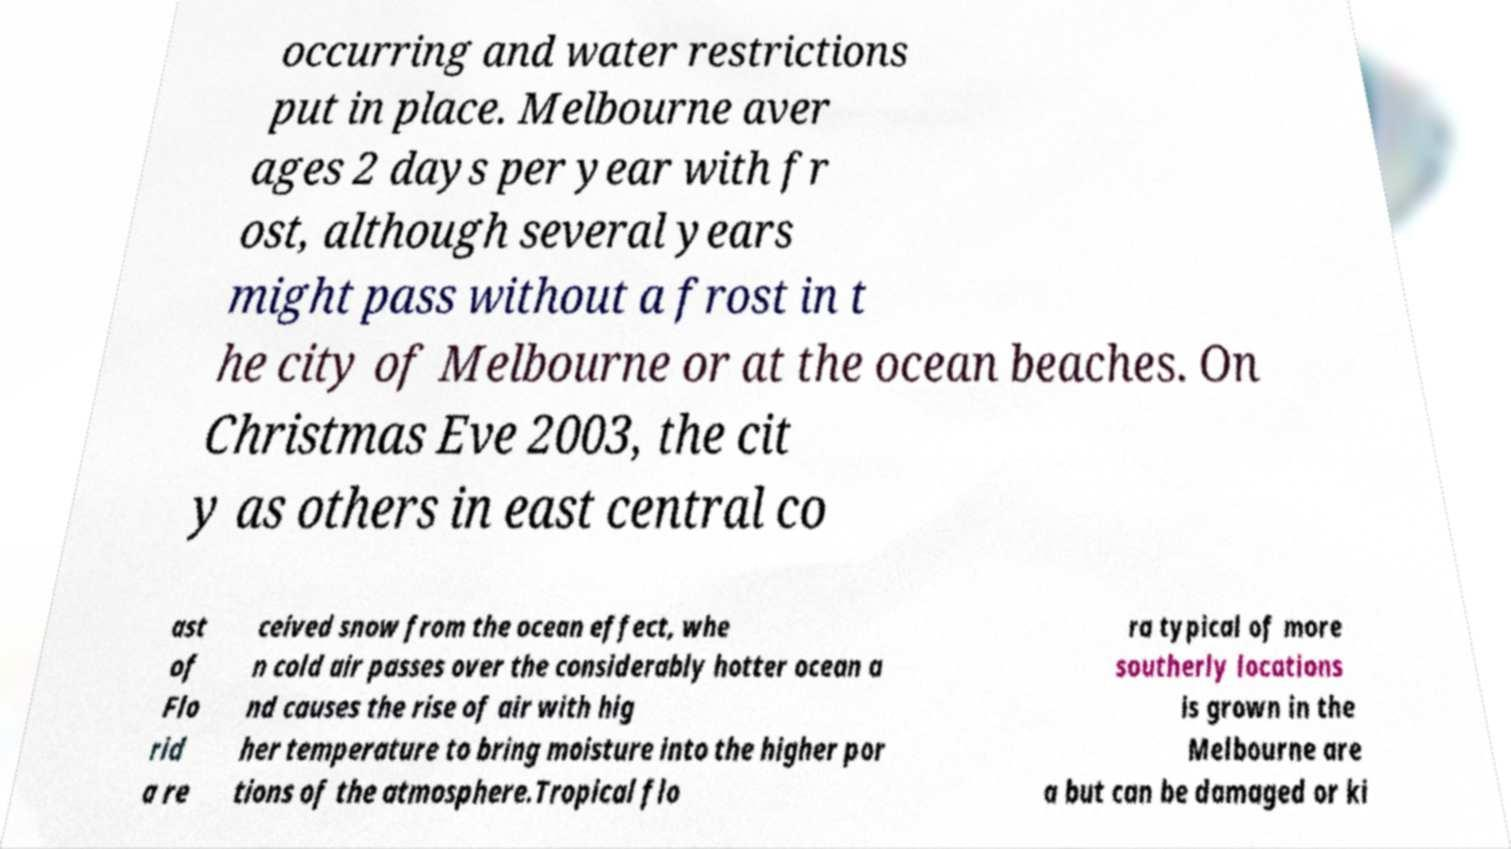Can you read and provide the text displayed in the image?This photo seems to have some interesting text. Can you extract and type it out for me? occurring and water restrictions put in place. Melbourne aver ages 2 days per year with fr ost, although several years might pass without a frost in t he city of Melbourne or at the ocean beaches. On Christmas Eve 2003, the cit y as others in east central co ast of Flo rid a re ceived snow from the ocean effect, whe n cold air passes over the considerably hotter ocean a nd causes the rise of air with hig her temperature to bring moisture into the higher por tions of the atmosphere.Tropical flo ra typical of more southerly locations is grown in the Melbourne are a but can be damaged or ki 